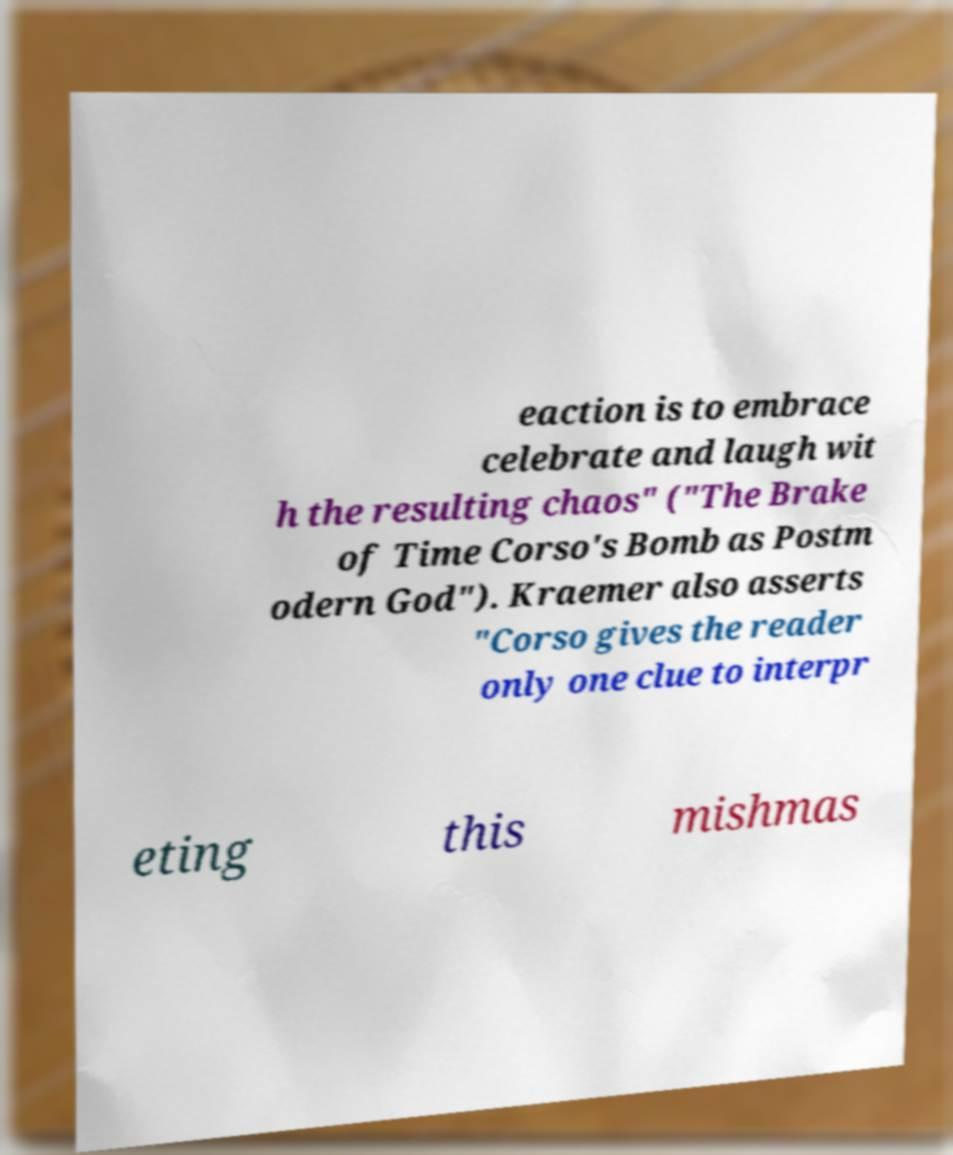Could you extract and type out the text from this image? eaction is to embrace celebrate and laugh wit h the resulting chaos" ("The Brake of Time Corso's Bomb as Postm odern God"). Kraemer also asserts "Corso gives the reader only one clue to interpr eting this mishmas 